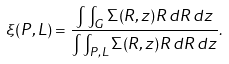Convert formula to latex. <formula><loc_0><loc_0><loc_500><loc_500>\xi ( P , L ) = \frac { \int \int _ { G } \Sigma ( R , z ) R \, d R \, d z } { \int \int _ { P , L } \Sigma ( R , z ) R \, d R \, d z } .</formula> 